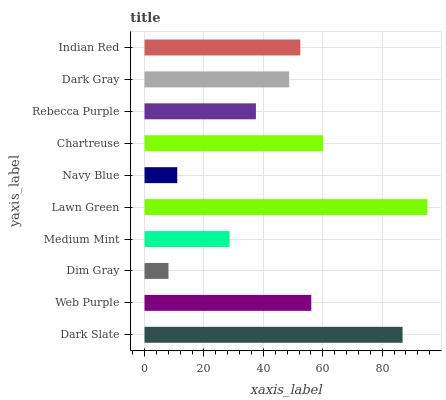Is Dim Gray the minimum?
Answer yes or no. Yes. Is Lawn Green the maximum?
Answer yes or no. Yes. Is Web Purple the minimum?
Answer yes or no. No. Is Web Purple the maximum?
Answer yes or no. No. Is Dark Slate greater than Web Purple?
Answer yes or no. Yes. Is Web Purple less than Dark Slate?
Answer yes or no. Yes. Is Web Purple greater than Dark Slate?
Answer yes or no. No. Is Dark Slate less than Web Purple?
Answer yes or no. No. Is Indian Red the high median?
Answer yes or no. Yes. Is Dark Gray the low median?
Answer yes or no. Yes. Is Medium Mint the high median?
Answer yes or no. No. Is Dim Gray the low median?
Answer yes or no. No. 